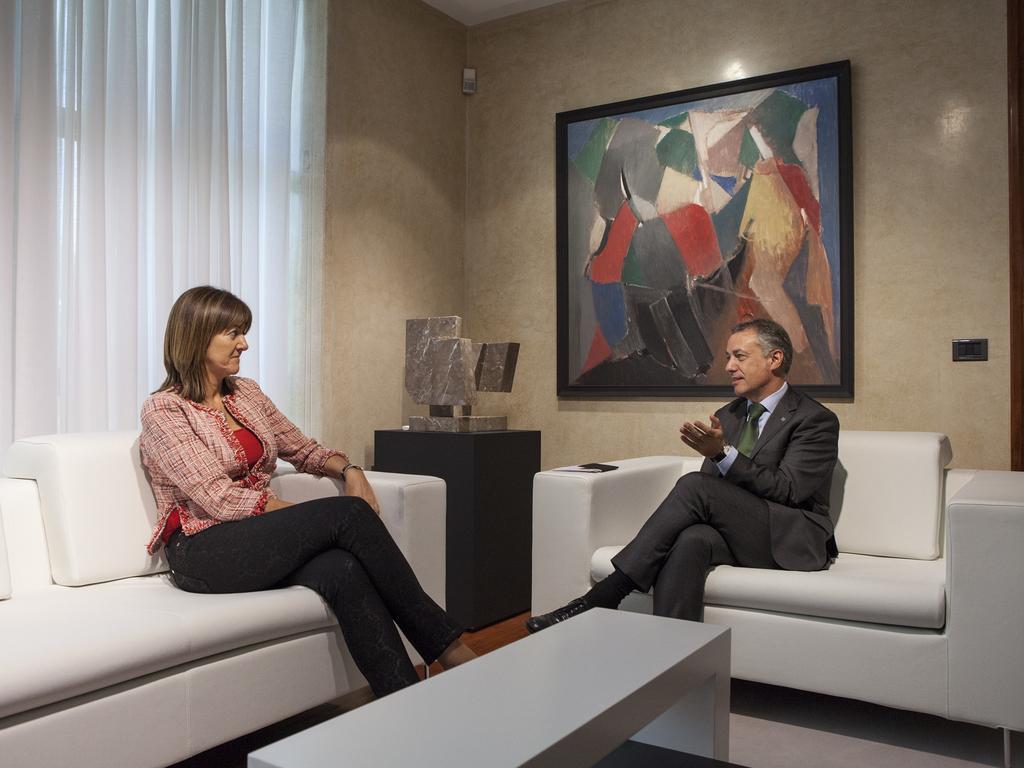Could you give a brief overview of what you see in this image? Here on the right side we can see a man sitting on a chair speaking something with the woman on the left side sitting on a couch and there is a table in front of them, here we can see a painting behind the man present and there are curtains present behind the woman 